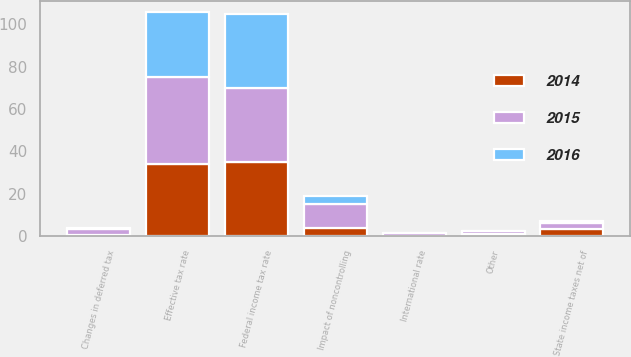Convert chart. <chart><loc_0><loc_0><loc_500><loc_500><stacked_bar_chart><ecel><fcel>Federal income tax rate<fcel>State income taxes net of<fcel>International rate<fcel>Changes in deferred tax<fcel>Other<fcel>Impact of noncontrolling<fcel>Effective tax rate<nl><fcel>2016<fcel>35<fcel>1.2<fcel>0.2<fcel>0.6<fcel>0.2<fcel>3.5<fcel>30.6<nl><fcel>2015<fcel>35<fcel>2.5<fcel>1.1<fcel>2.6<fcel>1.5<fcel>11.3<fcel>40.9<nl><fcel>2014<fcel>35<fcel>3.5<fcel>0.2<fcel>0.6<fcel>0.8<fcel>4<fcel>34.1<nl></chart> 